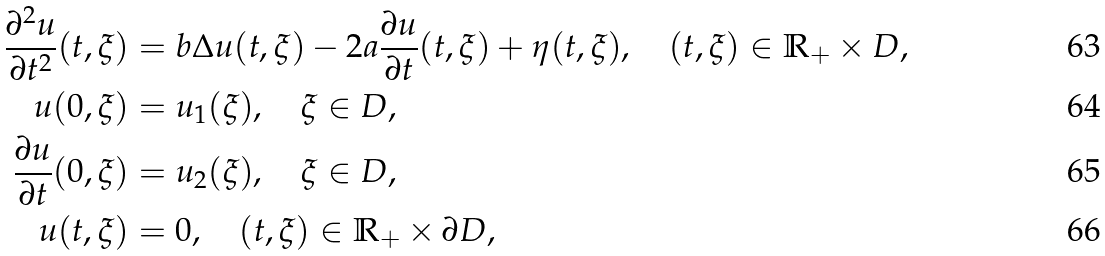Convert formula to latex. <formula><loc_0><loc_0><loc_500><loc_500>\frac { \partial ^ { 2 } u } { \partial t ^ { 2 } } ( t , \xi ) & = b \Delta u ( t , \xi ) - 2 a \frac { \partial u } { \partial t } ( t , \xi ) + \eta ( t , \xi ) , \quad ( t , \xi ) \in \mathbb { R } _ { + } \times D , \\ u ( 0 , \xi ) & = u _ { 1 } ( \xi ) , \quad \xi \in D , \\ \frac { \partial u } { \partial t } ( 0 , \xi ) & = u _ { 2 } ( \xi ) , \quad \xi \in D , \\ u ( t , \xi ) & = 0 , \quad ( t , \xi ) \in \mathbb { R } _ { + } \times \partial D ,</formula> 